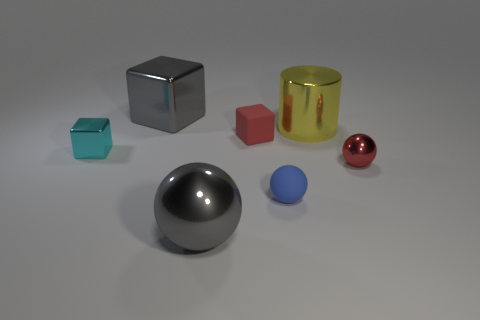Add 2 big yellow rubber cylinders. How many objects exist? 9 Subtract all balls. How many objects are left? 4 Subtract all large shiny objects. Subtract all gray balls. How many objects are left? 3 Add 1 tiny cyan things. How many tiny cyan things are left? 2 Add 5 small cyan cylinders. How many small cyan cylinders exist? 5 Subtract 1 red cubes. How many objects are left? 6 